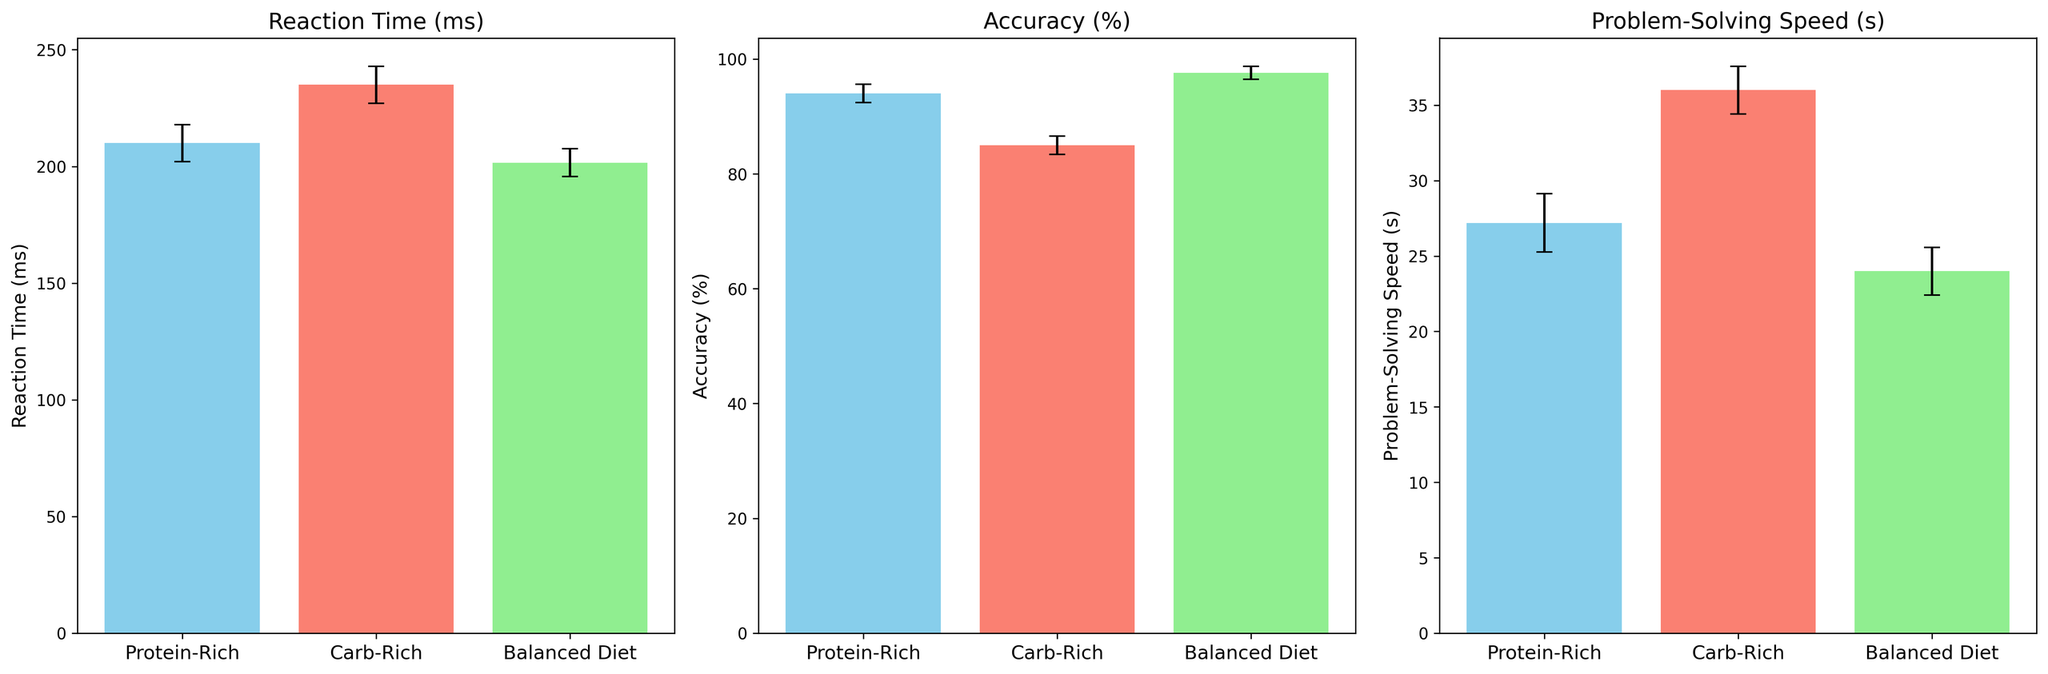What's the average reaction time for each meal type? To find the average reaction time, sum the reaction times for each meal type and then divide by the number of data points for that meal type. Protein-Rich: (210+215+205+220+200)/5 = 210 ms, Carb-Rich: (230+240+235+225+245)/5 = 235 ms, Balanced Diet: (200+195+205+210+198)/5 = 201.6 ms
Answer: Protein-Rich: 210 ms, Carb-Rich: 235 ms, Balanced Diet: 201.6 ms Which meal type has the highest accuracy on average? Look at the average accuracy values for each meal type and identify the highest one. Protein-Rich: (95+92+93+94+96)/5 = 94%, Carb-Rich: (85+87+84+86+83)/5 = 85%, Balanced Diet: (98+99+97+96+98)/5 = 97.6%
Answer: Balanced Diet: 97.6% Compare the problem-solving speed between Protein-Rich and Balanced Diet meals. Which one is faster on average? Calculate the average problem-solving speed for both meal types and compare them. Protein-Rich: (25+30+28+27+26)/5 = 27.2 s, Balanced Diet: (22+23+24+25+26)/5 = 24 s
Answer: Balanced Diet is faster on average What is the difference in average reaction time between Carb-Rich and Balanced Diet meals? Find the average reaction times for both meal types and then subtract the Balanced Diet average from the Carb-Rich average. Carb-Rich: 235 ms, Balanced Diet: 201.6 ms; Difference: 235 - 201.6 = 33.4 ms
Answer: 33.4 ms Which meal type has the most consistent accuracy, based on the smallest standard deviation? To find out, we need to compare the standard deviations of accuracy for each meal type. By visual inspection, if the error bars representing standard deviations are smallest for any meal type, it indicates consistency. From the plot, Balanced Diet has the smallest error bars for accuracy, indicating the highest consistency.
Answer: Balanced Diet What is the total combined problem-solving time for all meal types? Sum up all the problem-solving times provided in the data for all meal types. (Protein-Rich: 25+30+28+27+26) + (Carb-Rich: 35+34+36+37+38) + (Balanced Diet: 22+23+24+25+26) = 210 + 180 + 120 = 510 s
Answer: 510 s How does the average accuracy of Protein-Rich meals compare to the overall average accuracy across all meal types? First, find the overall average accuracy, then compare it to the Protein-Rich average. Overall accuracy: (95+92+93+94+96 + 85+87+84+86+83 + 98+99+97+96+98)/15 = 90.93%. Protein-Rich average: 94%. Comparison: Protein-Rich is higher.
Answer: Protein-Rich is higher Which meal type results in the fastest reaction time on average? Looking at the average reaction times, Protein-Rich: 210 ms, Carb-Rich: 235 ms, Balanced Diet: 201.6 ms. The smallest value indicates the fastest.
Answer: Balanced Diet Is there a significant difference in problem-solving speed between Carb-Rich and Protein-Rich meals? Calculate the average problem-solving speeds and compare, Carb-Rich: 36 s, Protein-Rich: 27.2 s. Difference: 36 - 27.2 = 8.8 s
Answer: Yes, 8.8 seconds What visually distinctive feature helps to quickly identify the meal type with the highest accuracy in the plot? Identify the visual characteristic (i.e., bar height) that shows the highest metric. Balanced Diet bars are the tallest in the accuracy subplot.
Answer: Tallest bars in accuracy subplot 